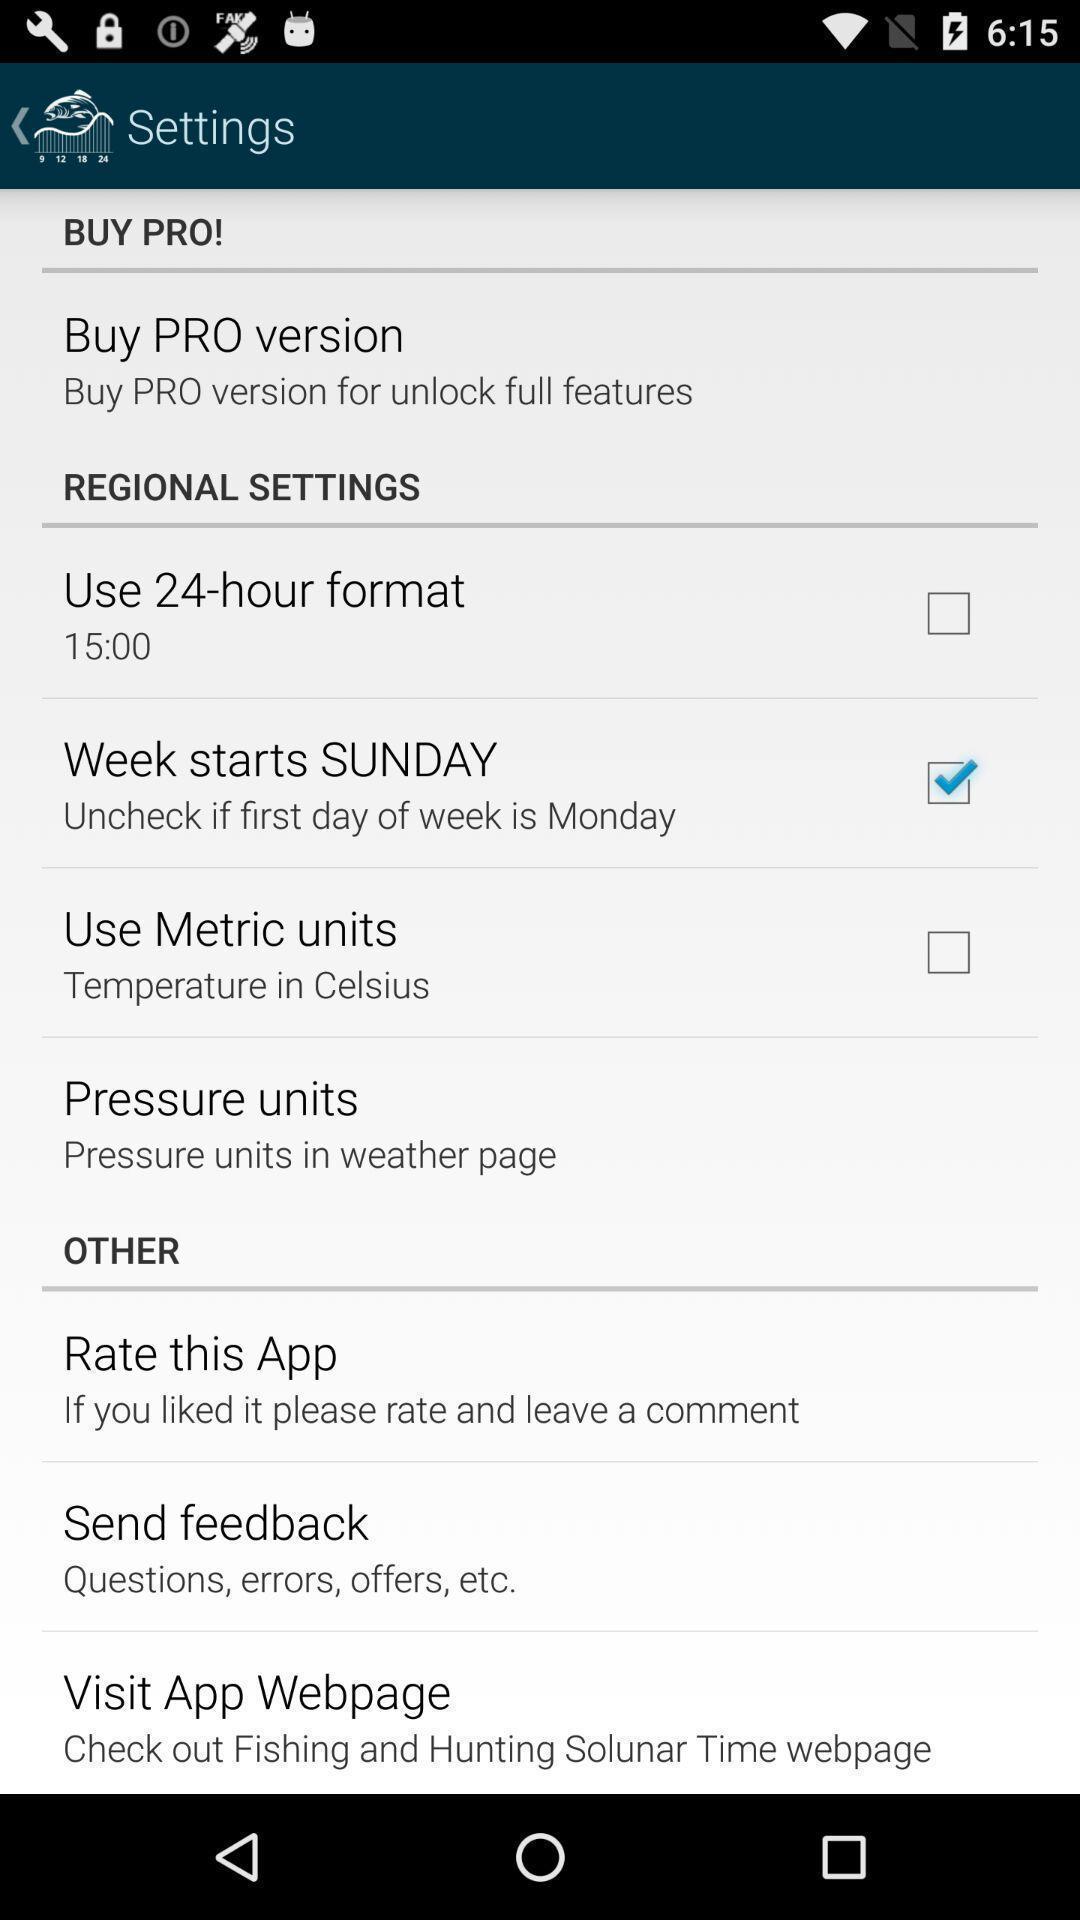Tell me about the visual elements in this screen capture. Settings page. 